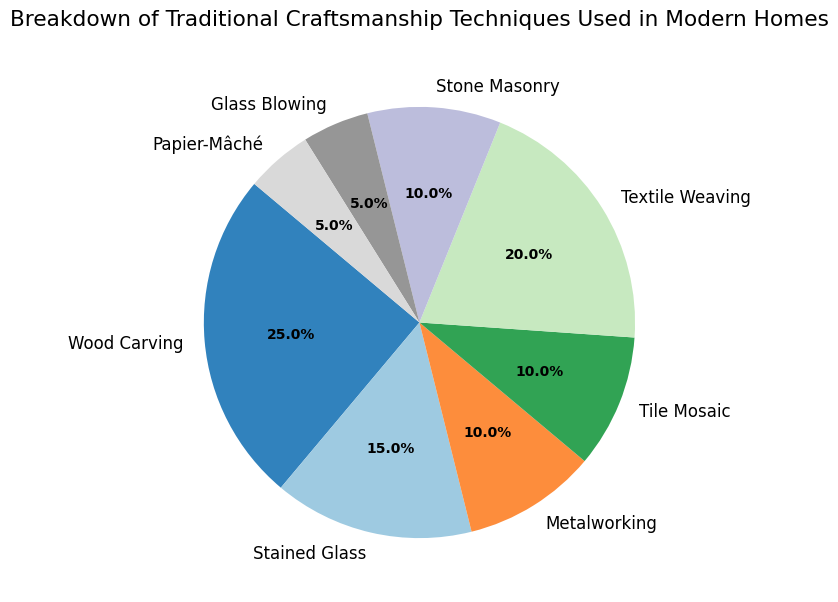What are the top three craftsmanship techniques used in modern homes by percentage? First, identify the techniques with the highest percentages. From the figure, the top three are Wood Carving (25%), Textile Weaving (20%), and Stained Glass (15%).
Answer: Wood Carving, Textile Weaving, Stained Glass Which craftsmanship technique has the lowest representation in modern homes? Look for the craftsmanship technique with the smallest percentage on the pie chart. It is Glass Blowing and Papier-Mâché, both at 5%.
Answer: Glass Blowing, Papier-Mâché How much more common is Wood Carving compared to Stone Masonry? Determine the percentages for Wood Carving (25%) and Stone Masonry (10%). Subtract the smaller percentage from the larger one: 25% - 10% = 15%.
Answer: 15% Is the combined percentage of Metalworking and Tile Mosaic greater than Textile Weaving? Find the percentages for Metalworking (10%) and Tile Mosaic (10%), then add them: 10% + 10% = 20%. Textile Weaving is also 20%, so they are equal.
Answer: No, they are equal What is the total percentage of traditional craftsmanship techniques that involve working with glass? Identify the techniques related to glass: Stained Glass (15%) and Glass Blowing (5%). Add them: 15% + 5% = 20%.
Answer: 20% Compared to Metalworking, how much higher is the percentage of Textile Weaving? Find the percentages for Metalworking (10%) and Textile Weaving (20%). Subtract the smaller from the larger: 20% - 10% = 10%.
Answer: 10% Which craftsmanship technique shown in the chart has the second lowest utilization, and what is its percentage? Identify the second smallest percentage following Glass Blowing and Papier-Mâché (both at 5%). The next smallest is Metalworking and Stone Masonry, both at 10%.
Answer: Metalworking, Stone Masonry (10%) What is the difference in percentage between the most and least used craftsmanship techniques? The most used technique is Wood Carving (25%), and the least used are Glass Blowing and Papier-Mâché (5%). Subtract the smallest from the largest: 25% - 5% = 20%.
Answer: 20% 